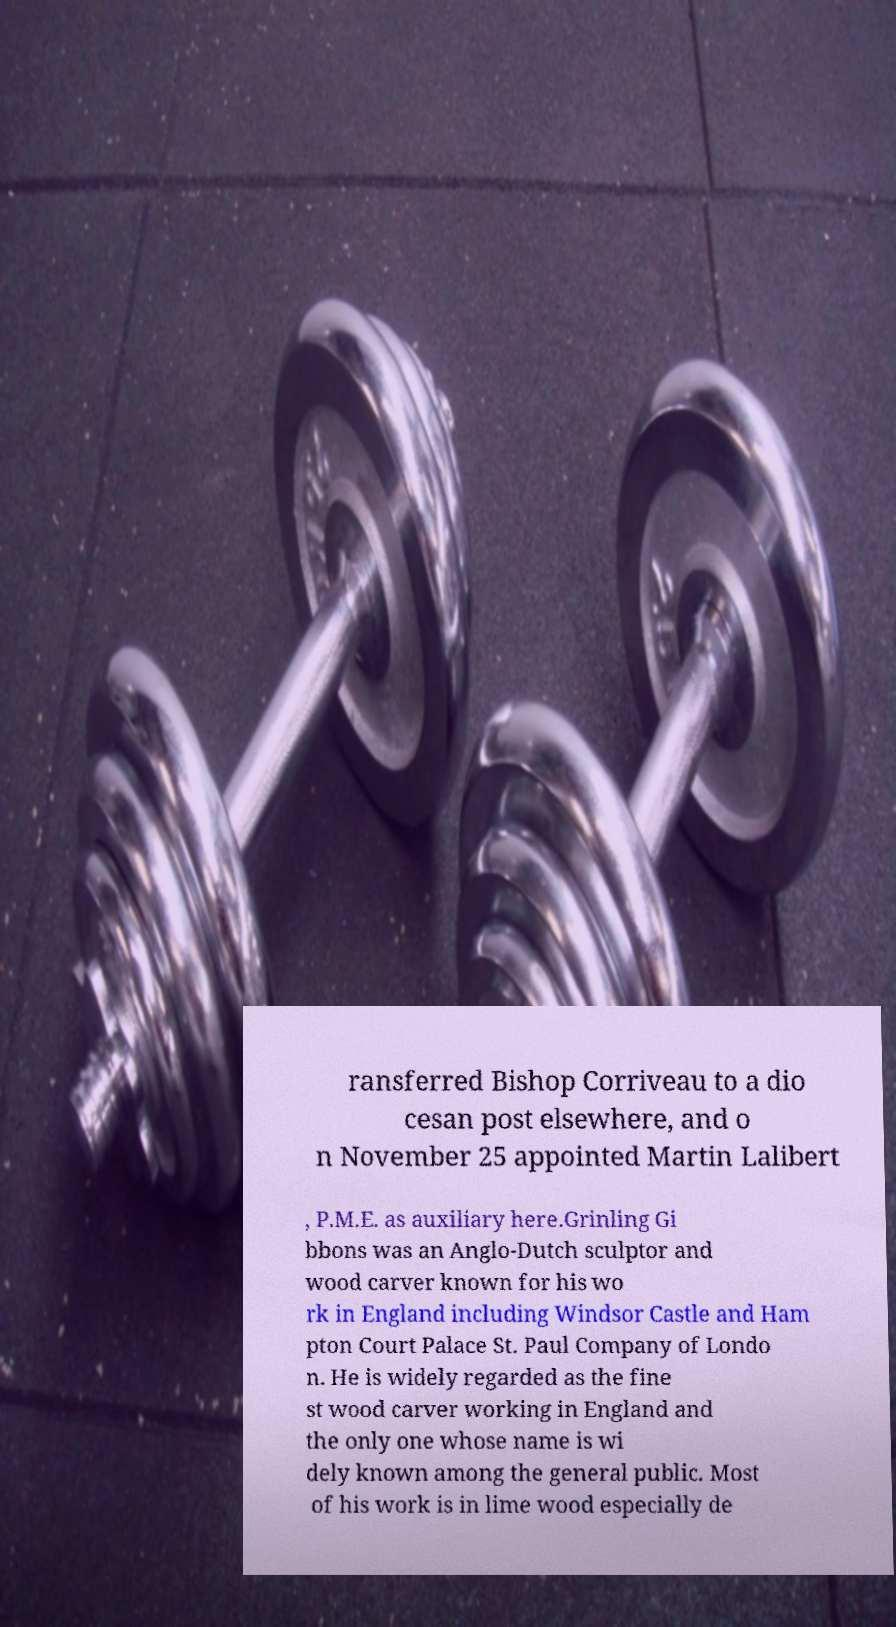For documentation purposes, I need the text within this image transcribed. Could you provide that? ransferred Bishop Corriveau to a dio cesan post elsewhere, and o n November 25 appointed Martin Lalibert , P.M.E. as auxiliary here.Grinling Gi bbons was an Anglo-Dutch sculptor and wood carver known for his wo rk in England including Windsor Castle and Ham pton Court Palace St. Paul Company of Londo n. He is widely regarded as the fine st wood carver working in England and the only one whose name is wi dely known among the general public. Most of his work is in lime wood especially de 